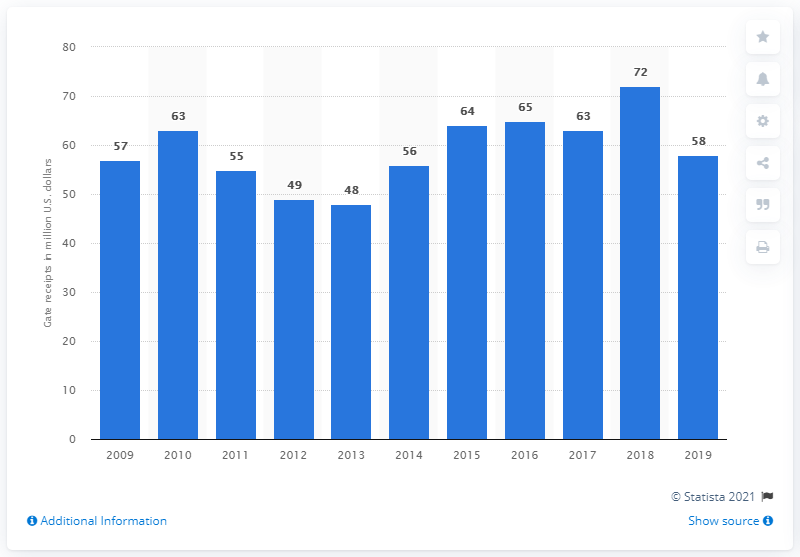Outline some significant characteristics in this image. The gate receipts of the Seattle Mariners in 2019 were approximately $58 million. 